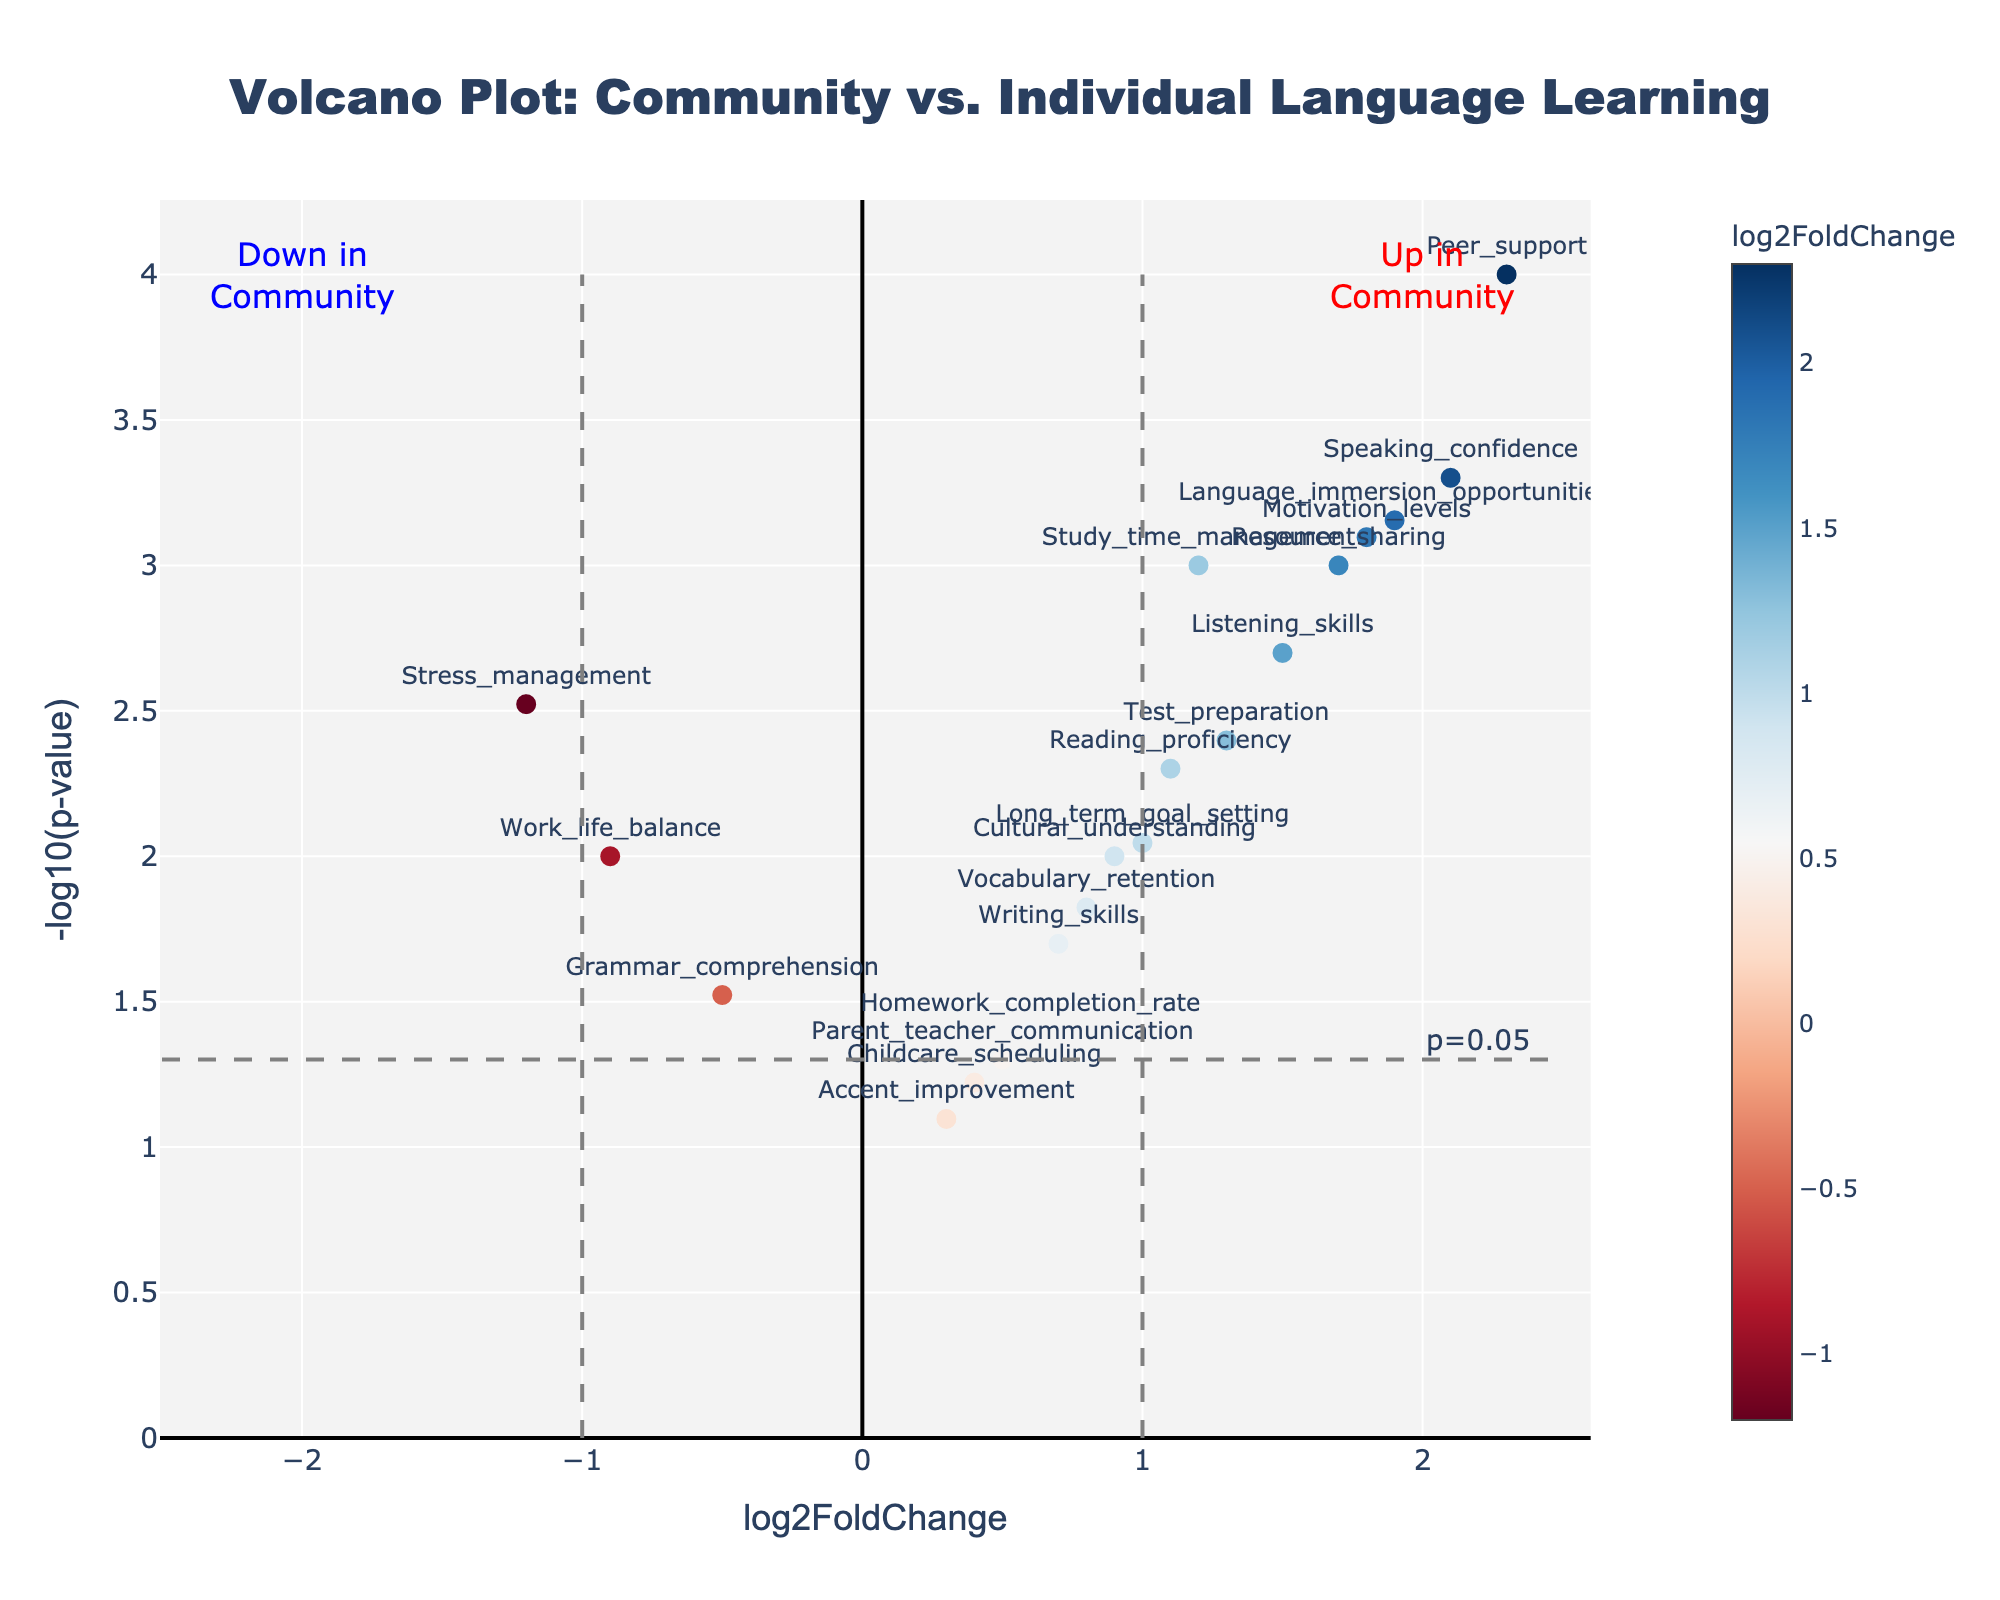What is the title of the Volcano Plot? The title "Volcano Plot: Community vs. Individual Language Learning" is prominently displayed at the top-center of the plot.
Answer: Volcano Plot: Community vs. Individual Language Learning Which axis represents the -log10(p-value)? The y-axis represents -log10(p-value), as indicated by its title on the left side of the plot.
Answer: y-axis How many data points have a log2FoldChange greater than 1? By visually examining the x-axis, data points with a log2FoldChange greater than 1 are the ones located to the right of x=1. These include "Speaking_confidence," "Motivation_levels," "Peer_support," "Resource_sharing," "Language_immersion_opportunities," "Test_preparation," and "Study_time_management," making the total equal to 8.
Answer: 8 Which gene has the highest -log10(p-value) value? By looking at the y-axis values, the gene with the highest -log10(p-value) value is "Peer_support," as it is positioned at the highest point on the y-axis.
Answer: Peer_support What does the dashed horizontal line at y=-log10(0.05) represent? The dashed horizontal line at y=-log10(0.05) represents the p-value threshold of 0.05. Points above this line are considered statistically significant. The annotation "p=0.05" further clarifies its purpose.
Answer: p-value threshold of 0.05 Which genes are significantly upregulated in community learning compared to studying alone? Data points on the right side of the plot and above the horizontal threshold (y=-log10(0.05)) indicate upregulation. These include "Peer_support," "Speaking_confidence," "Language_immersion_opportunities," "Motivation_levels," "Resource_sharing," and "Listening_skills."
Answer: Peer_support, Speaking_confidence, Language_immersion_opportunities, Motivation_levels, Resource_sharing, Listening_skills Which gene is downregulated the most in community learning? The gene with the lowest log2FoldChange and a significant p-value (above the horizontal threshold) is "Stress_management," indicating it's the most downregulated.
Answer: Stress_management Compare the log2FoldChange values of "Vocabulary_retention" and "Homework_completion_rate." Which one is higher? By examining the labels and positions, "Vocabulary_retention" has a log2FoldChange of 0.8, while "Homework_completion_rate" has a log2FoldChange of 0.6. The log2FoldChange for "Vocabulary_retention" is higher.
Answer: Vocabulary_retention What is the p-value of the gene "Reading_proficiency" and is it statistically significant? According to the hover text or y-axis value, the p-value of "Reading_proficiency" is 0.005. Since it is below 0.05, it is statistically significant.
Answer: 0.005, Yes Are there any genes with a log2FoldChange less than -1? If so, name them. By observing the x-axis, the only gene with a log2FoldChange less than -1 is "Stress_management."
Answer: Stress_management 